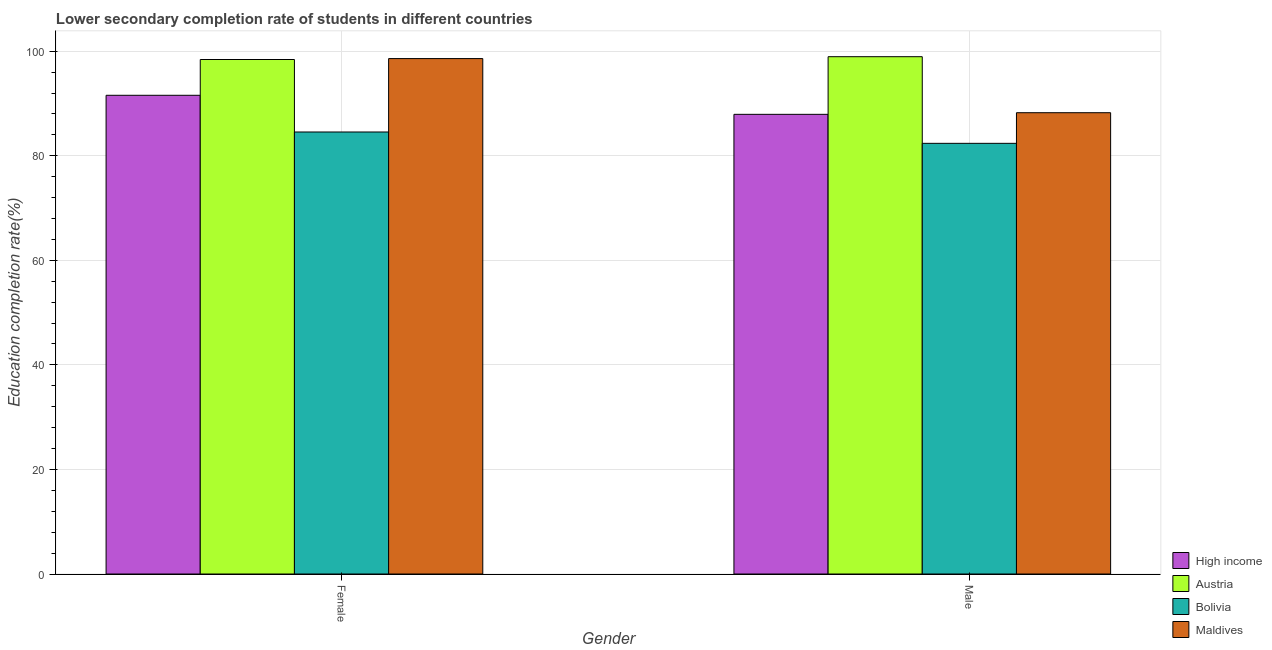How many different coloured bars are there?
Offer a terse response. 4. How many bars are there on the 1st tick from the left?
Provide a short and direct response. 4. What is the education completion rate of female students in Maldives?
Your answer should be compact. 98.59. Across all countries, what is the maximum education completion rate of male students?
Keep it short and to the point. 98.95. Across all countries, what is the minimum education completion rate of female students?
Offer a very short reply. 84.55. In which country was the education completion rate of male students maximum?
Your response must be concise. Austria. What is the total education completion rate of male students in the graph?
Your answer should be compact. 357.5. What is the difference between the education completion rate of female students in Maldives and that in Austria?
Your response must be concise. 0.18. What is the difference between the education completion rate of female students in Austria and the education completion rate of male students in Maldives?
Provide a succinct answer. 10.18. What is the average education completion rate of female students per country?
Keep it short and to the point. 93.28. What is the difference between the education completion rate of male students and education completion rate of female students in Austria?
Ensure brevity in your answer.  0.54. In how many countries, is the education completion rate of female students greater than 4 %?
Provide a succinct answer. 4. What is the ratio of the education completion rate of female students in High income to that in Austria?
Offer a terse response. 0.93. Is the education completion rate of female students in Bolivia less than that in Austria?
Keep it short and to the point. Yes. What does the 1st bar from the right in Female represents?
Your answer should be compact. Maldives. How many bars are there?
Offer a very short reply. 8. Are all the bars in the graph horizontal?
Ensure brevity in your answer.  No. How many countries are there in the graph?
Your response must be concise. 4. What is the difference between two consecutive major ticks on the Y-axis?
Offer a very short reply. 20. Does the graph contain any zero values?
Offer a very short reply. No. Does the graph contain grids?
Your answer should be very brief. Yes. What is the title of the graph?
Keep it short and to the point. Lower secondary completion rate of students in different countries. What is the label or title of the X-axis?
Provide a succinct answer. Gender. What is the label or title of the Y-axis?
Provide a short and direct response. Education completion rate(%). What is the Education completion rate(%) of High income in Female?
Ensure brevity in your answer.  91.57. What is the Education completion rate(%) in Austria in Female?
Keep it short and to the point. 98.41. What is the Education completion rate(%) of Bolivia in Female?
Your answer should be very brief. 84.55. What is the Education completion rate(%) of Maldives in Female?
Your answer should be very brief. 98.59. What is the Education completion rate(%) of High income in Male?
Ensure brevity in your answer.  87.93. What is the Education completion rate(%) of Austria in Male?
Your answer should be compact. 98.95. What is the Education completion rate(%) in Bolivia in Male?
Provide a succinct answer. 82.38. What is the Education completion rate(%) in Maldives in Male?
Make the answer very short. 88.24. Across all Gender, what is the maximum Education completion rate(%) of High income?
Keep it short and to the point. 91.57. Across all Gender, what is the maximum Education completion rate(%) of Austria?
Offer a very short reply. 98.95. Across all Gender, what is the maximum Education completion rate(%) of Bolivia?
Ensure brevity in your answer.  84.55. Across all Gender, what is the maximum Education completion rate(%) in Maldives?
Make the answer very short. 98.59. Across all Gender, what is the minimum Education completion rate(%) in High income?
Keep it short and to the point. 87.93. Across all Gender, what is the minimum Education completion rate(%) in Austria?
Give a very brief answer. 98.41. Across all Gender, what is the minimum Education completion rate(%) in Bolivia?
Your answer should be compact. 82.38. Across all Gender, what is the minimum Education completion rate(%) in Maldives?
Keep it short and to the point. 88.24. What is the total Education completion rate(%) of High income in the graph?
Your answer should be very brief. 179.5. What is the total Education completion rate(%) in Austria in the graph?
Offer a very short reply. 197.37. What is the total Education completion rate(%) in Bolivia in the graph?
Give a very brief answer. 166.93. What is the total Education completion rate(%) in Maldives in the graph?
Keep it short and to the point. 186.83. What is the difference between the Education completion rate(%) in High income in Female and that in Male?
Provide a short and direct response. 3.64. What is the difference between the Education completion rate(%) of Austria in Female and that in Male?
Offer a very short reply. -0.54. What is the difference between the Education completion rate(%) of Bolivia in Female and that in Male?
Keep it short and to the point. 2.17. What is the difference between the Education completion rate(%) of Maldives in Female and that in Male?
Give a very brief answer. 10.36. What is the difference between the Education completion rate(%) in High income in Female and the Education completion rate(%) in Austria in Male?
Your answer should be compact. -7.38. What is the difference between the Education completion rate(%) of High income in Female and the Education completion rate(%) of Bolivia in Male?
Give a very brief answer. 9.19. What is the difference between the Education completion rate(%) in High income in Female and the Education completion rate(%) in Maldives in Male?
Keep it short and to the point. 3.33. What is the difference between the Education completion rate(%) in Austria in Female and the Education completion rate(%) in Bolivia in Male?
Ensure brevity in your answer.  16.03. What is the difference between the Education completion rate(%) of Austria in Female and the Education completion rate(%) of Maldives in Male?
Offer a terse response. 10.18. What is the difference between the Education completion rate(%) in Bolivia in Female and the Education completion rate(%) in Maldives in Male?
Provide a short and direct response. -3.69. What is the average Education completion rate(%) in High income per Gender?
Keep it short and to the point. 89.75. What is the average Education completion rate(%) in Austria per Gender?
Give a very brief answer. 98.68. What is the average Education completion rate(%) in Bolivia per Gender?
Your response must be concise. 83.47. What is the average Education completion rate(%) of Maldives per Gender?
Your answer should be very brief. 93.41. What is the difference between the Education completion rate(%) of High income and Education completion rate(%) of Austria in Female?
Offer a very short reply. -6.84. What is the difference between the Education completion rate(%) in High income and Education completion rate(%) in Bolivia in Female?
Keep it short and to the point. 7.02. What is the difference between the Education completion rate(%) of High income and Education completion rate(%) of Maldives in Female?
Provide a succinct answer. -7.02. What is the difference between the Education completion rate(%) of Austria and Education completion rate(%) of Bolivia in Female?
Provide a succinct answer. 13.86. What is the difference between the Education completion rate(%) of Austria and Education completion rate(%) of Maldives in Female?
Provide a succinct answer. -0.18. What is the difference between the Education completion rate(%) in Bolivia and Education completion rate(%) in Maldives in Female?
Keep it short and to the point. -14.04. What is the difference between the Education completion rate(%) of High income and Education completion rate(%) of Austria in Male?
Your answer should be compact. -11.03. What is the difference between the Education completion rate(%) of High income and Education completion rate(%) of Bolivia in Male?
Your answer should be very brief. 5.55. What is the difference between the Education completion rate(%) in High income and Education completion rate(%) in Maldives in Male?
Your answer should be compact. -0.31. What is the difference between the Education completion rate(%) of Austria and Education completion rate(%) of Bolivia in Male?
Your response must be concise. 16.57. What is the difference between the Education completion rate(%) in Austria and Education completion rate(%) in Maldives in Male?
Provide a succinct answer. 10.72. What is the difference between the Education completion rate(%) in Bolivia and Education completion rate(%) in Maldives in Male?
Your answer should be compact. -5.86. What is the ratio of the Education completion rate(%) in High income in Female to that in Male?
Make the answer very short. 1.04. What is the ratio of the Education completion rate(%) of Austria in Female to that in Male?
Ensure brevity in your answer.  0.99. What is the ratio of the Education completion rate(%) of Bolivia in Female to that in Male?
Your answer should be very brief. 1.03. What is the ratio of the Education completion rate(%) of Maldives in Female to that in Male?
Give a very brief answer. 1.12. What is the difference between the highest and the second highest Education completion rate(%) in High income?
Ensure brevity in your answer.  3.64. What is the difference between the highest and the second highest Education completion rate(%) in Austria?
Give a very brief answer. 0.54. What is the difference between the highest and the second highest Education completion rate(%) of Bolivia?
Ensure brevity in your answer.  2.17. What is the difference between the highest and the second highest Education completion rate(%) in Maldives?
Ensure brevity in your answer.  10.36. What is the difference between the highest and the lowest Education completion rate(%) of High income?
Your answer should be very brief. 3.64. What is the difference between the highest and the lowest Education completion rate(%) of Austria?
Your response must be concise. 0.54. What is the difference between the highest and the lowest Education completion rate(%) of Bolivia?
Give a very brief answer. 2.17. What is the difference between the highest and the lowest Education completion rate(%) in Maldives?
Your answer should be compact. 10.36. 